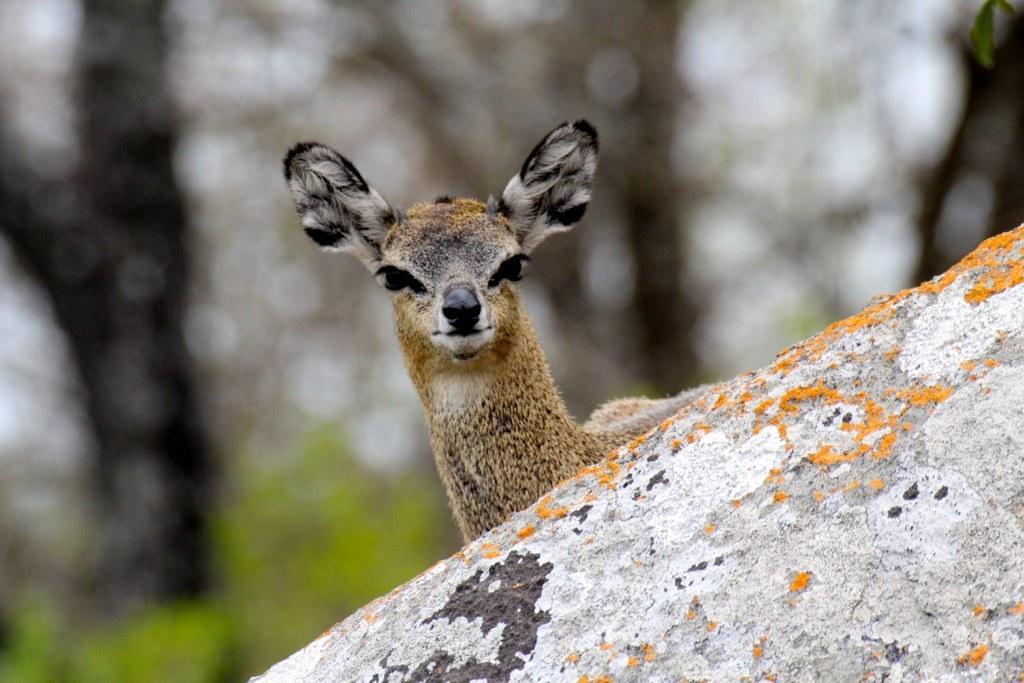Could you give a brief overview of what you see in this image? In this image we can see a white tailed deer and a rock. 